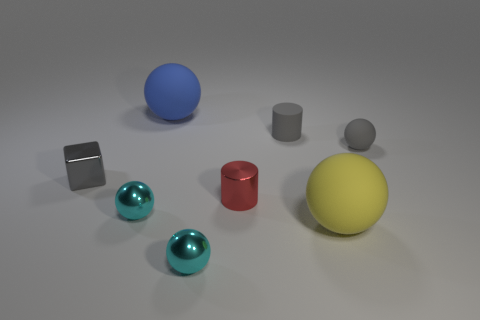Which of these objects is closest to the camera? The largest yellow sphere is closest to the camera, positioned prominently in the foreground of the image. Does its size affect the perception of depth in this image? Absolutely, the size of the yellow sphere relative to the other objects amplifies the sense of depth in the image. Its prominence in the foreground compared to the smaller objects receding in the background creates a strong perspective, enhancing the three-dimensional feel of the scene. 